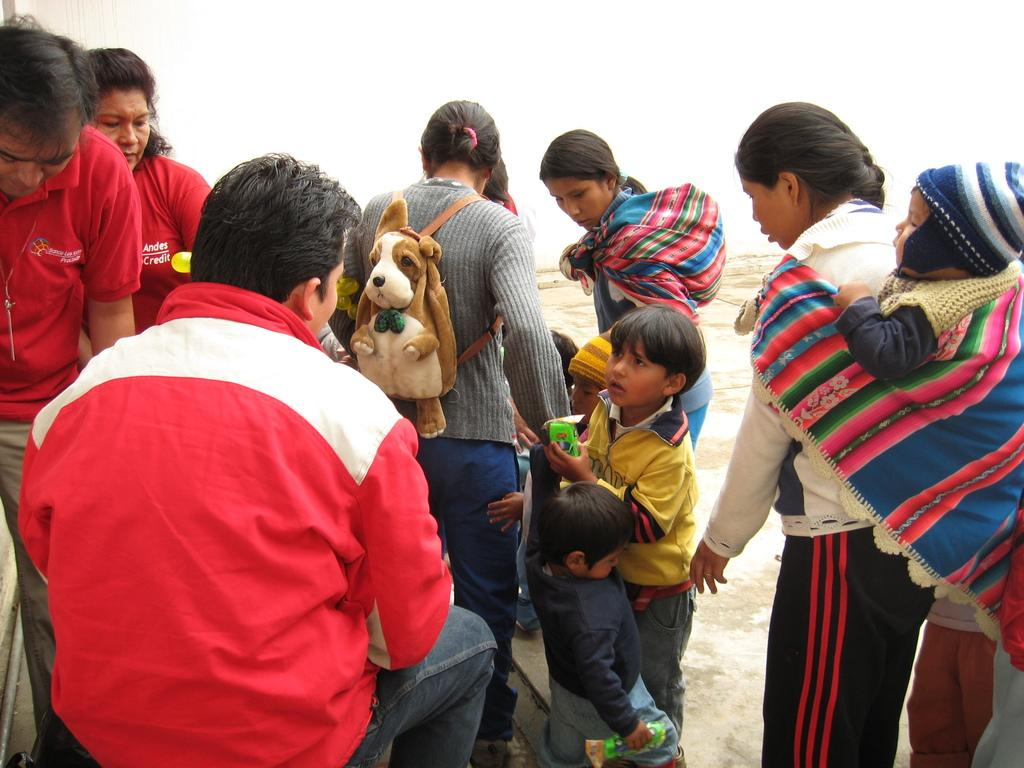What types of people are present in the image? There are men, women, and kids in the image. Can you describe the woman in the center of the image? The woman in the center of the image is wearing a bag. What other details can be observed about the people in the image? There are no additional details provided about the people in the image. What type of cable is being used by the friend in the image? There is no friend or cable present in the image. How many apples are being held by the kids in the image? There is no mention of apples in the image; the focus is on the presence of men, women, and kids. 